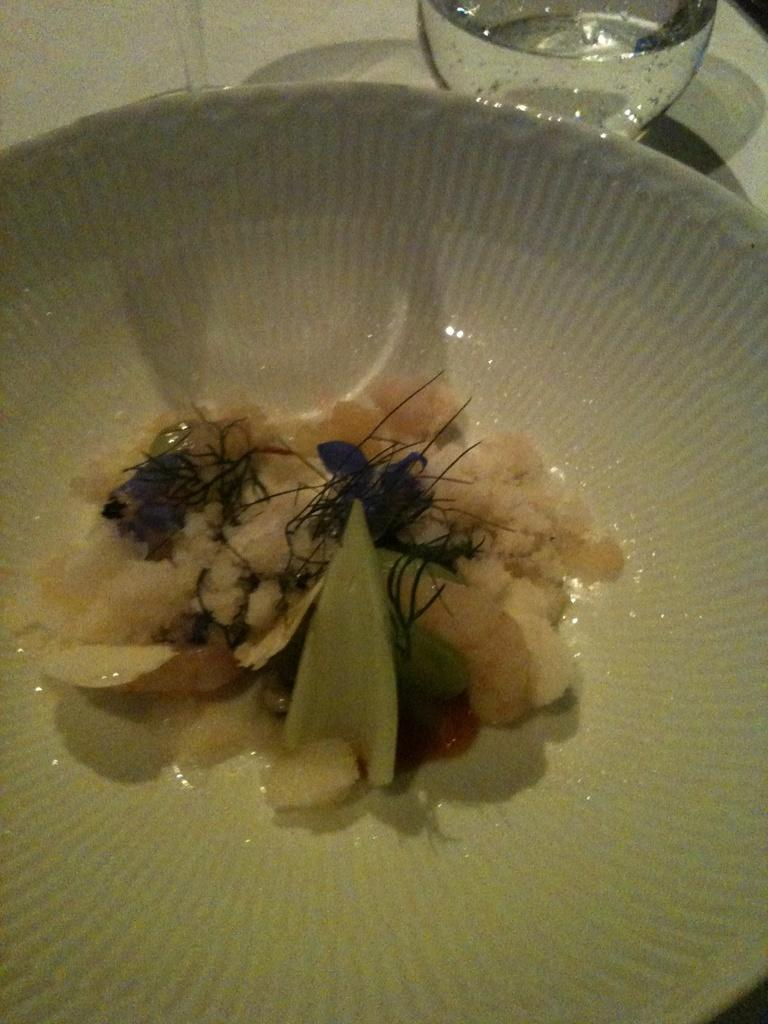What color is the bowl in the image? The bowl in the image is white. What is inside the bowl? The bowl contains food. Where is the bowl located? The bowl is placed on a table. What is the liquid in the glass beside the bowl? The glass contains water. How is the glass positioned in relation to the bowl? The glass is placed beside the bowl. Where are the bookshelves located in the image? There are no bookshelves present in the image. What type of machine is used to prepare the food in the bowl? There is no machine visible in the image, and the method of preparing the food is not mentioned. 